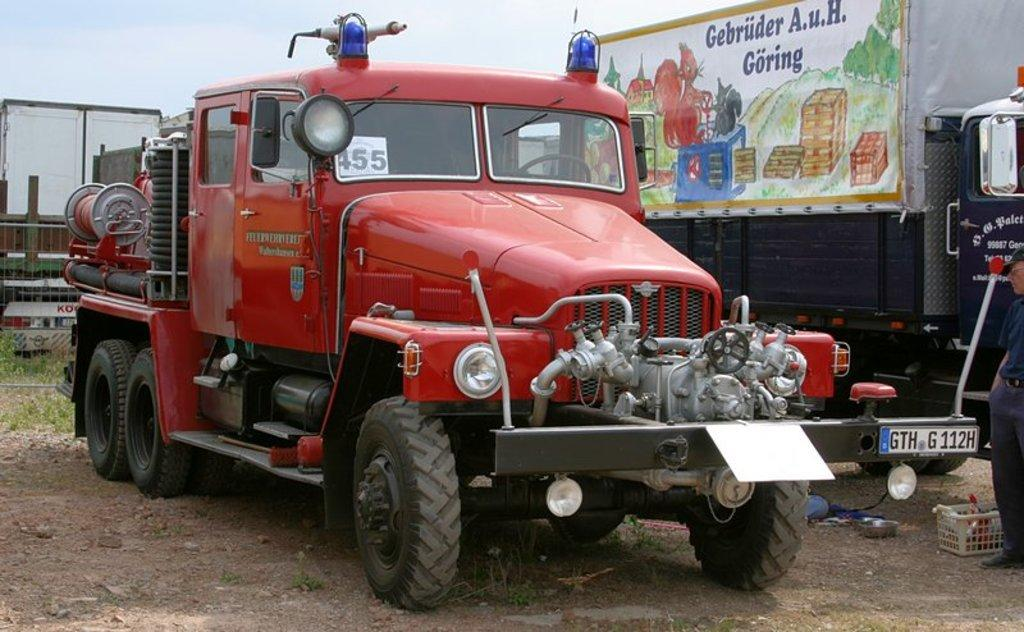What type of objects are on the ground in the image? There are vehicles on the ground in the image. What else can be seen in the image besides the vehicles? There is a banner, a basket, and a bowl in the image. What is visible at the top of the image? The sky is visible at the top of the image. What color is the silver thought in the image? There is no silver thought present in the image. What season is depicted in the image? The provided facts do not mention any season, so it cannot be determined from the image. 